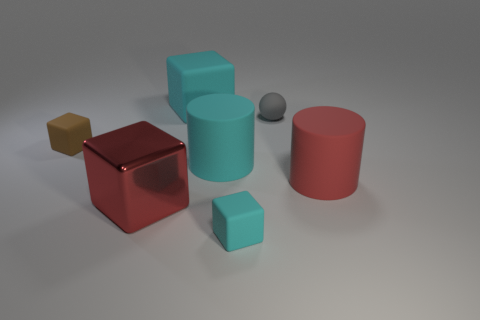Do the tiny matte object in front of the big red metal thing and the small brown rubber thing have the same shape?
Your answer should be very brief. Yes. Are there more big rubber cubes to the left of the small gray ball than tiny brown rubber blocks in front of the red metallic block?
Your response must be concise. Yes. How many small blocks are behind the big rubber cylinder that is on the left side of the small rubber ball?
Ensure brevity in your answer.  1. What is the material of the thing that is the same color as the metallic block?
Your answer should be very brief. Rubber. How many other objects are there of the same color as the metallic block?
Ensure brevity in your answer.  1. What color is the small object on the left side of the cyan cube that is behind the cyan matte cylinder?
Provide a succinct answer. Brown. Is there another tiny matte sphere that has the same color as the sphere?
Your response must be concise. No. How many metallic objects are either big cyan blocks or big gray balls?
Provide a succinct answer. 0. Are there any small gray objects that have the same material as the small brown thing?
Offer a terse response. Yes. How many small things are both to the left of the rubber sphere and behind the large shiny thing?
Provide a short and direct response. 1. 